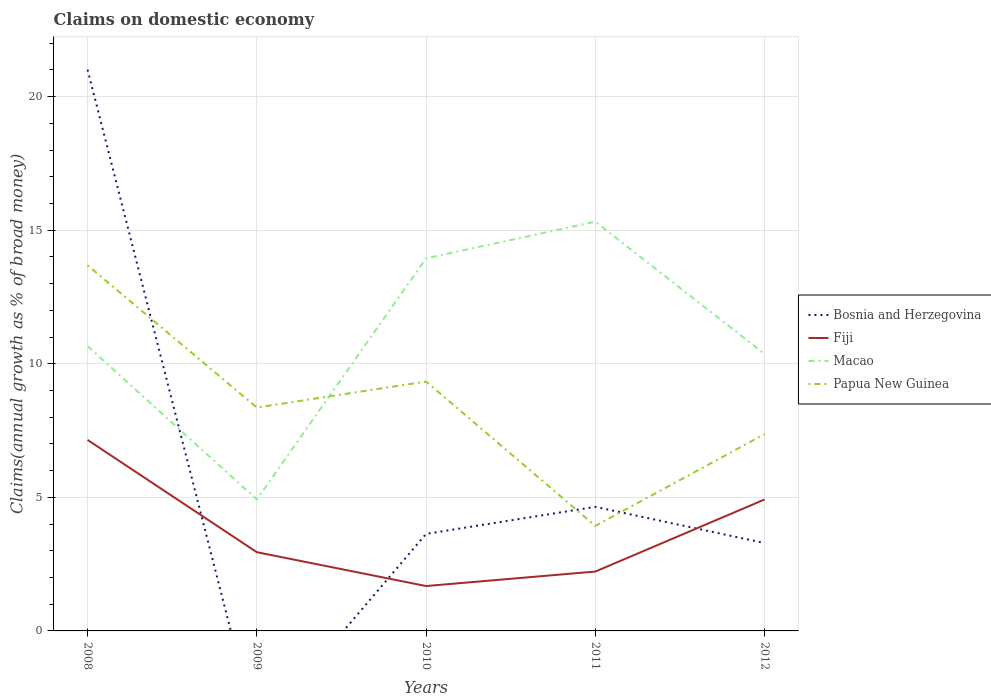Does the line corresponding to Macao intersect with the line corresponding to Bosnia and Herzegovina?
Offer a very short reply. Yes. Across all years, what is the maximum percentage of broad money claimed on domestic economy in Bosnia and Herzegovina?
Ensure brevity in your answer.  0. What is the total percentage of broad money claimed on domestic economy in Papua New Guinea in the graph?
Your answer should be compact. 4.43. What is the difference between the highest and the second highest percentage of broad money claimed on domestic economy in Macao?
Provide a succinct answer. 10.4. Does the graph contain any zero values?
Keep it short and to the point. Yes. How many legend labels are there?
Your response must be concise. 4. How are the legend labels stacked?
Your response must be concise. Vertical. What is the title of the graph?
Your answer should be compact. Claims on domestic economy. What is the label or title of the X-axis?
Give a very brief answer. Years. What is the label or title of the Y-axis?
Offer a very short reply. Claims(annual growth as % of broad money). What is the Claims(annual growth as % of broad money) of Bosnia and Herzegovina in 2008?
Make the answer very short. 21.01. What is the Claims(annual growth as % of broad money) in Fiji in 2008?
Your response must be concise. 7.15. What is the Claims(annual growth as % of broad money) of Macao in 2008?
Offer a terse response. 10.66. What is the Claims(annual growth as % of broad money) in Papua New Guinea in 2008?
Your answer should be very brief. 13.68. What is the Claims(annual growth as % of broad money) of Fiji in 2009?
Offer a terse response. 2.95. What is the Claims(annual growth as % of broad money) of Macao in 2009?
Provide a succinct answer. 4.92. What is the Claims(annual growth as % of broad money) in Papua New Guinea in 2009?
Offer a very short reply. 8.36. What is the Claims(annual growth as % of broad money) in Bosnia and Herzegovina in 2010?
Make the answer very short. 3.63. What is the Claims(annual growth as % of broad money) of Fiji in 2010?
Provide a succinct answer. 1.68. What is the Claims(annual growth as % of broad money) of Macao in 2010?
Ensure brevity in your answer.  13.95. What is the Claims(annual growth as % of broad money) of Papua New Guinea in 2010?
Ensure brevity in your answer.  9.33. What is the Claims(annual growth as % of broad money) of Bosnia and Herzegovina in 2011?
Your answer should be very brief. 4.64. What is the Claims(annual growth as % of broad money) of Fiji in 2011?
Keep it short and to the point. 2.22. What is the Claims(annual growth as % of broad money) of Macao in 2011?
Ensure brevity in your answer.  15.32. What is the Claims(annual growth as % of broad money) of Papua New Guinea in 2011?
Give a very brief answer. 3.93. What is the Claims(annual growth as % of broad money) of Bosnia and Herzegovina in 2012?
Make the answer very short. 3.29. What is the Claims(annual growth as % of broad money) in Fiji in 2012?
Your answer should be compact. 4.92. What is the Claims(annual growth as % of broad money) in Macao in 2012?
Give a very brief answer. 10.36. What is the Claims(annual growth as % of broad money) of Papua New Guinea in 2012?
Keep it short and to the point. 7.37. Across all years, what is the maximum Claims(annual growth as % of broad money) of Bosnia and Herzegovina?
Keep it short and to the point. 21.01. Across all years, what is the maximum Claims(annual growth as % of broad money) in Fiji?
Make the answer very short. 7.15. Across all years, what is the maximum Claims(annual growth as % of broad money) in Macao?
Keep it short and to the point. 15.32. Across all years, what is the maximum Claims(annual growth as % of broad money) of Papua New Guinea?
Offer a terse response. 13.68. Across all years, what is the minimum Claims(annual growth as % of broad money) in Fiji?
Your answer should be compact. 1.68. Across all years, what is the minimum Claims(annual growth as % of broad money) in Macao?
Your answer should be compact. 4.92. Across all years, what is the minimum Claims(annual growth as % of broad money) in Papua New Guinea?
Ensure brevity in your answer.  3.93. What is the total Claims(annual growth as % of broad money) in Bosnia and Herzegovina in the graph?
Provide a short and direct response. 32.57. What is the total Claims(annual growth as % of broad money) of Fiji in the graph?
Your response must be concise. 18.92. What is the total Claims(annual growth as % of broad money) in Macao in the graph?
Provide a short and direct response. 55.21. What is the total Claims(annual growth as % of broad money) in Papua New Guinea in the graph?
Your answer should be compact. 42.68. What is the difference between the Claims(annual growth as % of broad money) of Fiji in 2008 and that in 2009?
Your response must be concise. 4.2. What is the difference between the Claims(annual growth as % of broad money) of Macao in 2008 and that in 2009?
Ensure brevity in your answer.  5.74. What is the difference between the Claims(annual growth as % of broad money) in Papua New Guinea in 2008 and that in 2009?
Give a very brief answer. 5.32. What is the difference between the Claims(annual growth as % of broad money) in Bosnia and Herzegovina in 2008 and that in 2010?
Ensure brevity in your answer.  17.37. What is the difference between the Claims(annual growth as % of broad money) in Fiji in 2008 and that in 2010?
Offer a terse response. 5.47. What is the difference between the Claims(annual growth as % of broad money) of Macao in 2008 and that in 2010?
Make the answer very short. -3.29. What is the difference between the Claims(annual growth as % of broad money) in Papua New Guinea in 2008 and that in 2010?
Give a very brief answer. 4.35. What is the difference between the Claims(annual growth as % of broad money) in Bosnia and Herzegovina in 2008 and that in 2011?
Give a very brief answer. 16.36. What is the difference between the Claims(annual growth as % of broad money) in Fiji in 2008 and that in 2011?
Offer a very short reply. 4.93. What is the difference between the Claims(annual growth as % of broad money) in Macao in 2008 and that in 2011?
Keep it short and to the point. -4.66. What is the difference between the Claims(annual growth as % of broad money) in Papua New Guinea in 2008 and that in 2011?
Provide a succinct answer. 9.75. What is the difference between the Claims(annual growth as % of broad money) in Bosnia and Herzegovina in 2008 and that in 2012?
Ensure brevity in your answer.  17.72. What is the difference between the Claims(annual growth as % of broad money) in Fiji in 2008 and that in 2012?
Keep it short and to the point. 2.23. What is the difference between the Claims(annual growth as % of broad money) of Macao in 2008 and that in 2012?
Offer a terse response. 0.29. What is the difference between the Claims(annual growth as % of broad money) of Papua New Guinea in 2008 and that in 2012?
Make the answer very short. 6.32. What is the difference between the Claims(annual growth as % of broad money) of Fiji in 2009 and that in 2010?
Offer a very short reply. 1.27. What is the difference between the Claims(annual growth as % of broad money) in Macao in 2009 and that in 2010?
Your response must be concise. -9.02. What is the difference between the Claims(annual growth as % of broad money) of Papua New Guinea in 2009 and that in 2010?
Provide a short and direct response. -0.97. What is the difference between the Claims(annual growth as % of broad money) of Fiji in 2009 and that in 2011?
Offer a terse response. 0.72. What is the difference between the Claims(annual growth as % of broad money) of Macao in 2009 and that in 2011?
Provide a succinct answer. -10.4. What is the difference between the Claims(annual growth as % of broad money) of Papua New Guinea in 2009 and that in 2011?
Keep it short and to the point. 4.43. What is the difference between the Claims(annual growth as % of broad money) in Fiji in 2009 and that in 2012?
Offer a very short reply. -1.97. What is the difference between the Claims(annual growth as % of broad money) of Macao in 2009 and that in 2012?
Your response must be concise. -5.44. What is the difference between the Claims(annual growth as % of broad money) of Papua New Guinea in 2009 and that in 2012?
Ensure brevity in your answer.  1. What is the difference between the Claims(annual growth as % of broad money) of Bosnia and Herzegovina in 2010 and that in 2011?
Provide a succinct answer. -1.01. What is the difference between the Claims(annual growth as % of broad money) in Fiji in 2010 and that in 2011?
Ensure brevity in your answer.  -0.54. What is the difference between the Claims(annual growth as % of broad money) in Macao in 2010 and that in 2011?
Your response must be concise. -1.37. What is the difference between the Claims(annual growth as % of broad money) of Papua New Guinea in 2010 and that in 2011?
Give a very brief answer. 5.4. What is the difference between the Claims(annual growth as % of broad money) of Bosnia and Herzegovina in 2010 and that in 2012?
Your answer should be compact. 0.34. What is the difference between the Claims(annual growth as % of broad money) in Fiji in 2010 and that in 2012?
Offer a terse response. -3.24. What is the difference between the Claims(annual growth as % of broad money) of Macao in 2010 and that in 2012?
Provide a succinct answer. 3.58. What is the difference between the Claims(annual growth as % of broad money) of Papua New Guinea in 2010 and that in 2012?
Offer a very short reply. 1.97. What is the difference between the Claims(annual growth as % of broad money) of Bosnia and Herzegovina in 2011 and that in 2012?
Provide a succinct answer. 1.36. What is the difference between the Claims(annual growth as % of broad money) in Fiji in 2011 and that in 2012?
Offer a terse response. -2.7. What is the difference between the Claims(annual growth as % of broad money) in Macao in 2011 and that in 2012?
Provide a short and direct response. 4.95. What is the difference between the Claims(annual growth as % of broad money) in Papua New Guinea in 2011 and that in 2012?
Your response must be concise. -3.44. What is the difference between the Claims(annual growth as % of broad money) in Bosnia and Herzegovina in 2008 and the Claims(annual growth as % of broad money) in Fiji in 2009?
Your answer should be very brief. 18.06. What is the difference between the Claims(annual growth as % of broad money) of Bosnia and Herzegovina in 2008 and the Claims(annual growth as % of broad money) of Macao in 2009?
Provide a short and direct response. 16.09. What is the difference between the Claims(annual growth as % of broad money) of Bosnia and Herzegovina in 2008 and the Claims(annual growth as % of broad money) of Papua New Guinea in 2009?
Your response must be concise. 12.64. What is the difference between the Claims(annual growth as % of broad money) in Fiji in 2008 and the Claims(annual growth as % of broad money) in Macao in 2009?
Your answer should be very brief. 2.23. What is the difference between the Claims(annual growth as % of broad money) in Fiji in 2008 and the Claims(annual growth as % of broad money) in Papua New Guinea in 2009?
Your answer should be compact. -1.21. What is the difference between the Claims(annual growth as % of broad money) in Macao in 2008 and the Claims(annual growth as % of broad money) in Papua New Guinea in 2009?
Your answer should be compact. 2.3. What is the difference between the Claims(annual growth as % of broad money) in Bosnia and Herzegovina in 2008 and the Claims(annual growth as % of broad money) in Fiji in 2010?
Offer a terse response. 19.33. What is the difference between the Claims(annual growth as % of broad money) of Bosnia and Herzegovina in 2008 and the Claims(annual growth as % of broad money) of Macao in 2010?
Ensure brevity in your answer.  7.06. What is the difference between the Claims(annual growth as % of broad money) in Bosnia and Herzegovina in 2008 and the Claims(annual growth as % of broad money) in Papua New Guinea in 2010?
Ensure brevity in your answer.  11.67. What is the difference between the Claims(annual growth as % of broad money) of Fiji in 2008 and the Claims(annual growth as % of broad money) of Macao in 2010?
Provide a succinct answer. -6.8. What is the difference between the Claims(annual growth as % of broad money) in Fiji in 2008 and the Claims(annual growth as % of broad money) in Papua New Guinea in 2010?
Your answer should be compact. -2.18. What is the difference between the Claims(annual growth as % of broad money) of Macao in 2008 and the Claims(annual growth as % of broad money) of Papua New Guinea in 2010?
Your answer should be compact. 1.33. What is the difference between the Claims(annual growth as % of broad money) in Bosnia and Herzegovina in 2008 and the Claims(annual growth as % of broad money) in Fiji in 2011?
Provide a succinct answer. 18.78. What is the difference between the Claims(annual growth as % of broad money) of Bosnia and Herzegovina in 2008 and the Claims(annual growth as % of broad money) of Macao in 2011?
Your response must be concise. 5.69. What is the difference between the Claims(annual growth as % of broad money) of Bosnia and Herzegovina in 2008 and the Claims(annual growth as % of broad money) of Papua New Guinea in 2011?
Provide a short and direct response. 17.08. What is the difference between the Claims(annual growth as % of broad money) of Fiji in 2008 and the Claims(annual growth as % of broad money) of Macao in 2011?
Your answer should be very brief. -8.17. What is the difference between the Claims(annual growth as % of broad money) of Fiji in 2008 and the Claims(annual growth as % of broad money) of Papua New Guinea in 2011?
Give a very brief answer. 3.22. What is the difference between the Claims(annual growth as % of broad money) in Macao in 2008 and the Claims(annual growth as % of broad money) in Papua New Guinea in 2011?
Make the answer very short. 6.73. What is the difference between the Claims(annual growth as % of broad money) of Bosnia and Herzegovina in 2008 and the Claims(annual growth as % of broad money) of Fiji in 2012?
Your response must be concise. 16.09. What is the difference between the Claims(annual growth as % of broad money) of Bosnia and Herzegovina in 2008 and the Claims(annual growth as % of broad money) of Macao in 2012?
Your answer should be very brief. 10.64. What is the difference between the Claims(annual growth as % of broad money) of Bosnia and Herzegovina in 2008 and the Claims(annual growth as % of broad money) of Papua New Guinea in 2012?
Your answer should be very brief. 13.64. What is the difference between the Claims(annual growth as % of broad money) of Fiji in 2008 and the Claims(annual growth as % of broad money) of Macao in 2012?
Ensure brevity in your answer.  -3.22. What is the difference between the Claims(annual growth as % of broad money) in Fiji in 2008 and the Claims(annual growth as % of broad money) in Papua New Guinea in 2012?
Keep it short and to the point. -0.22. What is the difference between the Claims(annual growth as % of broad money) of Macao in 2008 and the Claims(annual growth as % of broad money) of Papua New Guinea in 2012?
Provide a short and direct response. 3.29. What is the difference between the Claims(annual growth as % of broad money) in Fiji in 2009 and the Claims(annual growth as % of broad money) in Macao in 2010?
Your answer should be compact. -11. What is the difference between the Claims(annual growth as % of broad money) of Fiji in 2009 and the Claims(annual growth as % of broad money) of Papua New Guinea in 2010?
Your answer should be compact. -6.39. What is the difference between the Claims(annual growth as % of broad money) of Macao in 2009 and the Claims(annual growth as % of broad money) of Papua New Guinea in 2010?
Make the answer very short. -4.41. What is the difference between the Claims(annual growth as % of broad money) in Fiji in 2009 and the Claims(annual growth as % of broad money) in Macao in 2011?
Provide a succinct answer. -12.37. What is the difference between the Claims(annual growth as % of broad money) of Fiji in 2009 and the Claims(annual growth as % of broad money) of Papua New Guinea in 2011?
Provide a succinct answer. -0.98. What is the difference between the Claims(annual growth as % of broad money) in Macao in 2009 and the Claims(annual growth as % of broad money) in Papua New Guinea in 2011?
Offer a very short reply. 0.99. What is the difference between the Claims(annual growth as % of broad money) of Fiji in 2009 and the Claims(annual growth as % of broad money) of Macao in 2012?
Make the answer very short. -7.42. What is the difference between the Claims(annual growth as % of broad money) of Fiji in 2009 and the Claims(annual growth as % of broad money) of Papua New Guinea in 2012?
Keep it short and to the point. -4.42. What is the difference between the Claims(annual growth as % of broad money) in Macao in 2009 and the Claims(annual growth as % of broad money) in Papua New Guinea in 2012?
Offer a terse response. -2.45. What is the difference between the Claims(annual growth as % of broad money) of Bosnia and Herzegovina in 2010 and the Claims(annual growth as % of broad money) of Fiji in 2011?
Make the answer very short. 1.41. What is the difference between the Claims(annual growth as % of broad money) of Bosnia and Herzegovina in 2010 and the Claims(annual growth as % of broad money) of Macao in 2011?
Provide a succinct answer. -11.69. What is the difference between the Claims(annual growth as % of broad money) of Bosnia and Herzegovina in 2010 and the Claims(annual growth as % of broad money) of Papua New Guinea in 2011?
Give a very brief answer. -0.3. What is the difference between the Claims(annual growth as % of broad money) in Fiji in 2010 and the Claims(annual growth as % of broad money) in Macao in 2011?
Give a very brief answer. -13.64. What is the difference between the Claims(annual growth as % of broad money) of Fiji in 2010 and the Claims(annual growth as % of broad money) of Papua New Guinea in 2011?
Provide a short and direct response. -2.25. What is the difference between the Claims(annual growth as % of broad money) in Macao in 2010 and the Claims(annual growth as % of broad money) in Papua New Guinea in 2011?
Provide a short and direct response. 10.02. What is the difference between the Claims(annual growth as % of broad money) of Bosnia and Herzegovina in 2010 and the Claims(annual growth as % of broad money) of Fiji in 2012?
Provide a succinct answer. -1.29. What is the difference between the Claims(annual growth as % of broad money) of Bosnia and Herzegovina in 2010 and the Claims(annual growth as % of broad money) of Macao in 2012?
Your answer should be compact. -6.73. What is the difference between the Claims(annual growth as % of broad money) of Bosnia and Herzegovina in 2010 and the Claims(annual growth as % of broad money) of Papua New Guinea in 2012?
Your answer should be compact. -3.73. What is the difference between the Claims(annual growth as % of broad money) in Fiji in 2010 and the Claims(annual growth as % of broad money) in Macao in 2012?
Your answer should be very brief. -8.69. What is the difference between the Claims(annual growth as % of broad money) of Fiji in 2010 and the Claims(annual growth as % of broad money) of Papua New Guinea in 2012?
Offer a terse response. -5.69. What is the difference between the Claims(annual growth as % of broad money) of Macao in 2010 and the Claims(annual growth as % of broad money) of Papua New Guinea in 2012?
Your answer should be compact. 6.58. What is the difference between the Claims(annual growth as % of broad money) of Bosnia and Herzegovina in 2011 and the Claims(annual growth as % of broad money) of Fiji in 2012?
Give a very brief answer. -0.27. What is the difference between the Claims(annual growth as % of broad money) of Bosnia and Herzegovina in 2011 and the Claims(annual growth as % of broad money) of Macao in 2012?
Give a very brief answer. -5.72. What is the difference between the Claims(annual growth as % of broad money) in Bosnia and Herzegovina in 2011 and the Claims(annual growth as % of broad money) in Papua New Guinea in 2012?
Keep it short and to the point. -2.72. What is the difference between the Claims(annual growth as % of broad money) in Fiji in 2011 and the Claims(annual growth as % of broad money) in Macao in 2012?
Make the answer very short. -8.14. What is the difference between the Claims(annual growth as % of broad money) of Fiji in 2011 and the Claims(annual growth as % of broad money) of Papua New Guinea in 2012?
Offer a terse response. -5.14. What is the difference between the Claims(annual growth as % of broad money) in Macao in 2011 and the Claims(annual growth as % of broad money) in Papua New Guinea in 2012?
Provide a short and direct response. 7.95. What is the average Claims(annual growth as % of broad money) in Bosnia and Herzegovina per year?
Ensure brevity in your answer.  6.51. What is the average Claims(annual growth as % of broad money) in Fiji per year?
Your answer should be compact. 3.78. What is the average Claims(annual growth as % of broad money) in Macao per year?
Offer a very short reply. 11.04. What is the average Claims(annual growth as % of broad money) of Papua New Guinea per year?
Ensure brevity in your answer.  8.54. In the year 2008, what is the difference between the Claims(annual growth as % of broad money) in Bosnia and Herzegovina and Claims(annual growth as % of broad money) in Fiji?
Offer a very short reply. 13.86. In the year 2008, what is the difference between the Claims(annual growth as % of broad money) in Bosnia and Herzegovina and Claims(annual growth as % of broad money) in Macao?
Offer a very short reply. 10.35. In the year 2008, what is the difference between the Claims(annual growth as % of broad money) in Bosnia and Herzegovina and Claims(annual growth as % of broad money) in Papua New Guinea?
Ensure brevity in your answer.  7.32. In the year 2008, what is the difference between the Claims(annual growth as % of broad money) in Fiji and Claims(annual growth as % of broad money) in Macao?
Keep it short and to the point. -3.51. In the year 2008, what is the difference between the Claims(annual growth as % of broad money) of Fiji and Claims(annual growth as % of broad money) of Papua New Guinea?
Give a very brief answer. -6.53. In the year 2008, what is the difference between the Claims(annual growth as % of broad money) in Macao and Claims(annual growth as % of broad money) in Papua New Guinea?
Keep it short and to the point. -3.02. In the year 2009, what is the difference between the Claims(annual growth as % of broad money) of Fiji and Claims(annual growth as % of broad money) of Macao?
Give a very brief answer. -1.97. In the year 2009, what is the difference between the Claims(annual growth as % of broad money) in Fiji and Claims(annual growth as % of broad money) in Papua New Guinea?
Provide a short and direct response. -5.41. In the year 2009, what is the difference between the Claims(annual growth as % of broad money) in Macao and Claims(annual growth as % of broad money) in Papua New Guinea?
Provide a succinct answer. -3.44. In the year 2010, what is the difference between the Claims(annual growth as % of broad money) in Bosnia and Herzegovina and Claims(annual growth as % of broad money) in Fiji?
Give a very brief answer. 1.95. In the year 2010, what is the difference between the Claims(annual growth as % of broad money) in Bosnia and Herzegovina and Claims(annual growth as % of broad money) in Macao?
Keep it short and to the point. -10.31. In the year 2010, what is the difference between the Claims(annual growth as % of broad money) of Bosnia and Herzegovina and Claims(annual growth as % of broad money) of Papua New Guinea?
Your answer should be compact. -5.7. In the year 2010, what is the difference between the Claims(annual growth as % of broad money) in Fiji and Claims(annual growth as % of broad money) in Macao?
Make the answer very short. -12.27. In the year 2010, what is the difference between the Claims(annual growth as % of broad money) in Fiji and Claims(annual growth as % of broad money) in Papua New Guinea?
Offer a very short reply. -7.65. In the year 2010, what is the difference between the Claims(annual growth as % of broad money) in Macao and Claims(annual growth as % of broad money) in Papua New Guinea?
Ensure brevity in your answer.  4.61. In the year 2011, what is the difference between the Claims(annual growth as % of broad money) of Bosnia and Herzegovina and Claims(annual growth as % of broad money) of Fiji?
Make the answer very short. 2.42. In the year 2011, what is the difference between the Claims(annual growth as % of broad money) of Bosnia and Herzegovina and Claims(annual growth as % of broad money) of Macao?
Provide a succinct answer. -10.67. In the year 2011, what is the difference between the Claims(annual growth as % of broad money) in Bosnia and Herzegovina and Claims(annual growth as % of broad money) in Papua New Guinea?
Provide a succinct answer. 0.71. In the year 2011, what is the difference between the Claims(annual growth as % of broad money) in Fiji and Claims(annual growth as % of broad money) in Macao?
Make the answer very short. -13.1. In the year 2011, what is the difference between the Claims(annual growth as % of broad money) of Fiji and Claims(annual growth as % of broad money) of Papua New Guinea?
Make the answer very short. -1.71. In the year 2011, what is the difference between the Claims(annual growth as % of broad money) of Macao and Claims(annual growth as % of broad money) of Papua New Guinea?
Make the answer very short. 11.39. In the year 2012, what is the difference between the Claims(annual growth as % of broad money) of Bosnia and Herzegovina and Claims(annual growth as % of broad money) of Fiji?
Provide a short and direct response. -1.63. In the year 2012, what is the difference between the Claims(annual growth as % of broad money) of Bosnia and Herzegovina and Claims(annual growth as % of broad money) of Macao?
Ensure brevity in your answer.  -7.08. In the year 2012, what is the difference between the Claims(annual growth as % of broad money) of Bosnia and Herzegovina and Claims(annual growth as % of broad money) of Papua New Guinea?
Ensure brevity in your answer.  -4.08. In the year 2012, what is the difference between the Claims(annual growth as % of broad money) of Fiji and Claims(annual growth as % of broad money) of Macao?
Your response must be concise. -5.45. In the year 2012, what is the difference between the Claims(annual growth as % of broad money) of Fiji and Claims(annual growth as % of broad money) of Papua New Guinea?
Offer a very short reply. -2.45. In the year 2012, what is the difference between the Claims(annual growth as % of broad money) in Macao and Claims(annual growth as % of broad money) in Papua New Guinea?
Offer a terse response. 3. What is the ratio of the Claims(annual growth as % of broad money) in Fiji in 2008 to that in 2009?
Give a very brief answer. 2.43. What is the ratio of the Claims(annual growth as % of broad money) of Macao in 2008 to that in 2009?
Offer a very short reply. 2.17. What is the ratio of the Claims(annual growth as % of broad money) of Papua New Guinea in 2008 to that in 2009?
Offer a terse response. 1.64. What is the ratio of the Claims(annual growth as % of broad money) of Bosnia and Herzegovina in 2008 to that in 2010?
Give a very brief answer. 5.78. What is the ratio of the Claims(annual growth as % of broad money) of Fiji in 2008 to that in 2010?
Give a very brief answer. 4.26. What is the ratio of the Claims(annual growth as % of broad money) in Macao in 2008 to that in 2010?
Offer a terse response. 0.76. What is the ratio of the Claims(annual growth as % of broad money) of Papua New Guinea in 2008 to that in 2010?
Give a very brief answer. 1.47. What is the ratio of the Claims(annual growth as % of broad money) in Bosnia and Herzegovina in 2008 to that in 2011?
Your response must be concise. 4.52. What is the ratio of the Claims(annual growth as % of broad money) of Fiji in 2008 to that in 2011?
Ensure brevity in your answer.  3.22. What is the ratio of the Claims(annual growth as % of broad money) in Macao in 2008 to that in 2011?
Give a very brief answer. 0.7. What is the ratio of the Claims(annual growth as % of broad money) in Papua New Guinea in 2008 to that in 2011?
Your answer should be very brief. 3.48. What is the ratio of the Claims(annual growth as % of broad money) in Bosnia and Herzegovina in 2008 to that in 2012?
Your answer should be very brief. 6.39. What is the ratio of the Claims(annual growth as % of broad money) of Fiji in 2008 to that in 2012?
Ensure brevity in your answer.  1.45. What is the ratio of the Claims(annual growth as % of broad money) in Macao in 2008 to that in 2012?
Your answer should be compact. 1.03. What is the ratio of the Claims(annual growth as % of broad money) in Papua New Guinea in 2008 to that in 2012?
Your answer should be compact. 1.86. What is the ratio of the Claims(annual growth as % of broad money) in Fiji in 2009 to that in 2010?
Ensure brevity in your answer.  1.75. What is the ratio of the Claims(annual growth as % of broad money) in Macao in 2009 to that in 2010?
Give a very brief answer. 0.35. What is the ratio of the Claims(annual growth as % of broad money) of Papua New Guinea in 2009 to that in 2010?
Your answer should be compact. 0.9. What is the ratio of the Claims(annual growth as % of broad money) of Fiji in 2009 to that in 2011?
Offer a very short reply. 1.33. What is the ratio of the Claims(annual growth as % of broad money) in Macao in 2009 to that in 2011?
Give a very brief answer. 0.32. What is the ratio of the Claims(annual growth as % of broad money) in Papua New Guinea in 2009 to that in 2011?
Provide a succinct answer. 2.13. What is the ratio of the Claims(annual growth as % of broad money) of Fiji in 2009 to that in 2012?
Provide a short and direct response. 0.6. What is the ratio of the Claims(annual growth as % of broad money) of Macao in 2009 to that in 2012?
Your response must be concise. 0.47. What is the ratio of the Claims(annual growth as % of broad money) of Papua New Guinea in 2009 to that in 2012?
Provide a succinct answer. 1.14. What is the ratio of the Claims(annual growth as % of broad money) of Bosnia and Herzegovina in 2010 to that in 2011?
Ensure brevity in your answer.  0.78. What is the ratio of the Claims(annual growth as % of broad money) of Fiji in 2010 to that in 2011?
Your response must be concise. 0.76. What is the ratio of the Claims(annual growth as % of broad money) in Macao in 2010 to that in 2011?
Your answer should be very brief. 0.91. What is the ratio of the Claims(annual growth as % of broad money) of Papua New Guinea in 2010 to that in 2011?
Your answer should be very brief. 2.38. What is the ratio of the Claims(annual growth as % of broad money) in Bosnia and Herzegovina in 2010 to that in 2012?
Provide a short and direct response. 1.1. What is the ratio of the Claims(annual growth as % of broad money) of Fiji in 2010 to that in 2012?
Provide a short and direct response. 0.34. What is the ratio of the Claims(annual growth as % of broad money) in Macao in 2010 to that in 2012?
Provide a succinct answer. 1.35. What is the ratio of the Claims(annual growth as % of broad money) of Papua New Guinea in 2010 to that in 2012?
Provide a succinct answer. 1.27. What is the ratio of the Claims(annual growth as % of broad money) in Bosnia and Herzegovina in 2011 to that in 2012?
Make the answer very short. 1.41. What is the ratio of the Claims(annual growth as % of broad money) in Fiji in 2011 to that in 2012?
Keep it short and to the point. 0.45. What is the ratio of the Claims(annual growth as % of broad money) in Macao in 2011 to that in 2012?
Your response must be concise. 1.48. What is the ratio of the Claims(annual growth as % of broad money) in Papua New Guinea in 2011 to that in 2012?
Your answer should be compact. 0.53. What is the difference between the highest and the second highest Claims(annual growth as % of broad money) of Bosnia and Herzegovina?
Offer a terse response. 16.36. What is the difference between the highest and the second highest Claims(annual growth as % of broad money) of Fiji?
Make the answer very short. 2.23. What is the difference between the highest and the second highest Claims(annual growth as % of broad money) of Macao?
Provide a short and direct response. 1.37. What is the difference between the highest and the second highest Claims(annual growth as % of broad money) in Papua New Guinea?
Keep it short and to the point. 4.35. What is the difference between the highest and the lowest Claims(annual growth as % of broad money) of Bosnia and Herzegovina?
Provide a short and direct response. 21.01. What is the difference between the highest and the lowest Claims(annual growth as % of broad money) of Fiji?
Offer a terse response. 5.47. What is the difference between the highest and the lowest Claims(annual growth as % of broad money) in Macao?
Offer a very short reply. 10.4. What is the difference between the highest and the lowest Claims(annual growth as % of broad money) in Papua New Guinea?
Provide a short and direct response. 9.75. 